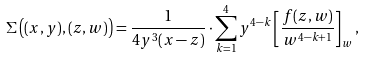Convert formula to latex. <formula><loc_0><loc_0><loc_500><loc_500>\Sigma \left ( ( x , y ) , ( z , w ) \right ) = \frac { 1 } { 4 y ^ { 3 } ( x - z ) } \cdot \sum _ { k = 1 } ^ { 4 } y ^ { 4 - k } \left [ \frac { f ( z , w ) } { w ^ { 4 - k + 1 } } \right ] _ { w } ,</formula> 